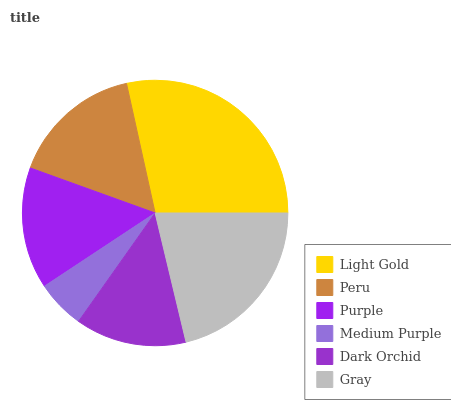Is Medium Purple the minimum?
Answer yes or no. Yes. Is Light Gold the maximum?
Answer yes or no. Yes. Is Peru the minimum?
Answer yes or no. No. Is Peru the maximum?
Answer yes or no. No. Is Light Gold greater than Peru?
Answer yes or no. Yes. Is Peru less than Light Gold?
Answer yes or no. Yes. Is Peru greater than Light Gold?
Answer yes or no. No. Is Light Gold less than Peru?
Answer yes or no. No. Is Peru the high median?
Answer yes or no. Yes. Is Purple the low median?
Answer yes or no. Yes. Is Gray the high median?
Answer yes or no. No. Is Dark Orchid the low median?
Answer yes or no. No. 